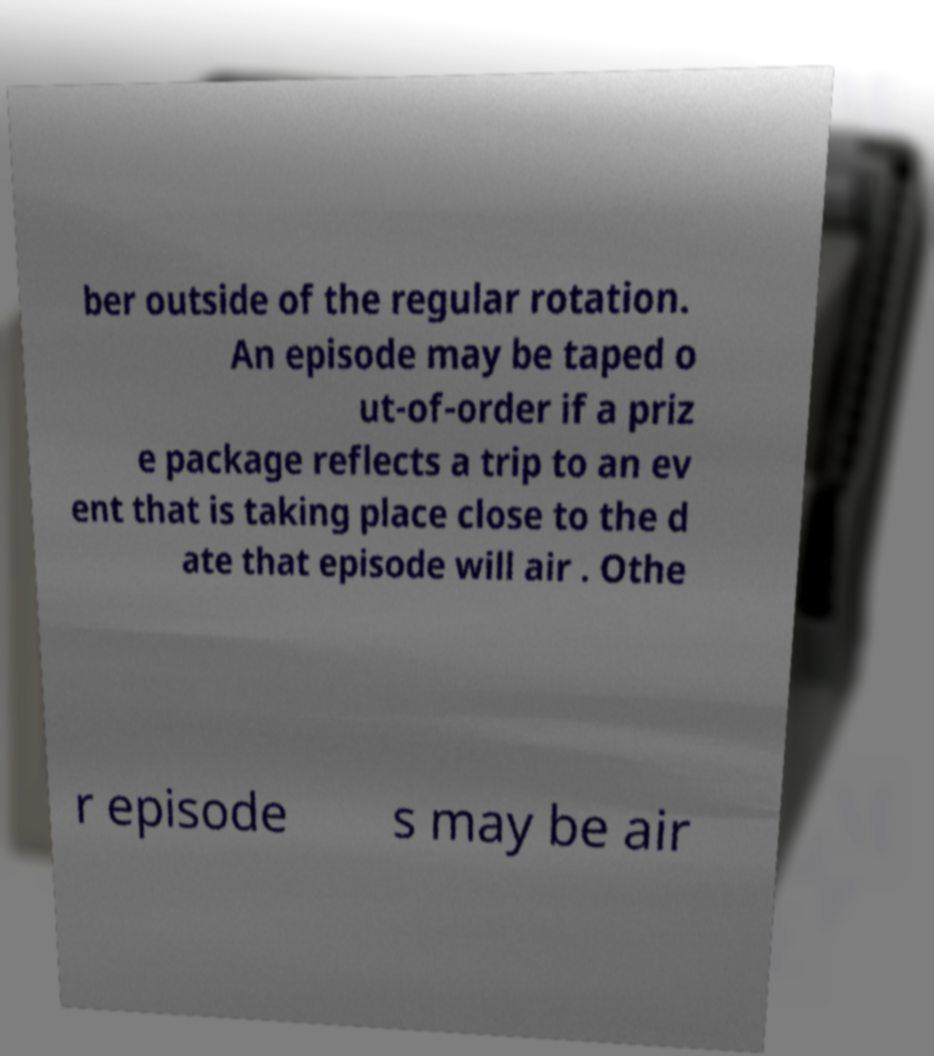There's text embedded in this image that I need extracted. Can you transcribe it verbatim? ber outside of the regular rotation. An episode may be taped o ut-of-order if a priz e package reflects a trip to an ev ent that is taking place close to the d ate that episode will air . Othe r episode s may be air 